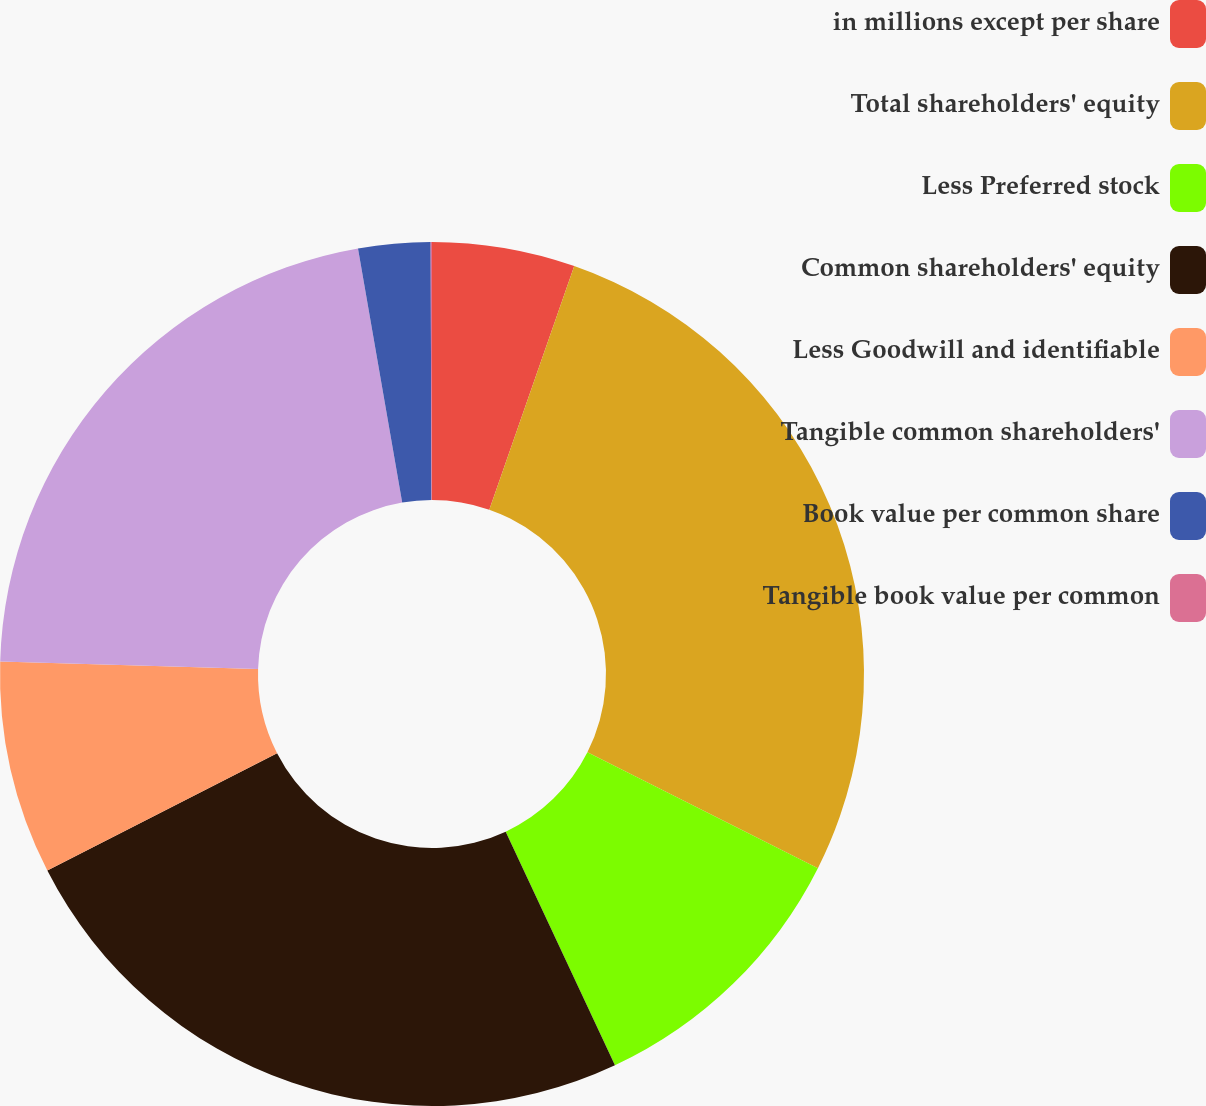Convert chart to OTSL. <chart><loc_0><loc_0><loc_500><loc_500><pie_chart><fcel>in millions except per share<fcel>Total shareholders' equity<fcel>Less Preferred stock<fcel>Common shareholders' equity<fcel>Less Goodwill and identifiable<fcel>Tangible common shareholders'<fcel>Book value per common share<fcel>Tangible book value per common<nl><fcel>5.34%<fcel>27.08%<fcel>10.62%<fcel>24.44%<fcel>7.98%<fcel>21.8%<fcel>2.69%<fcel>0.05%<nl></chart> 